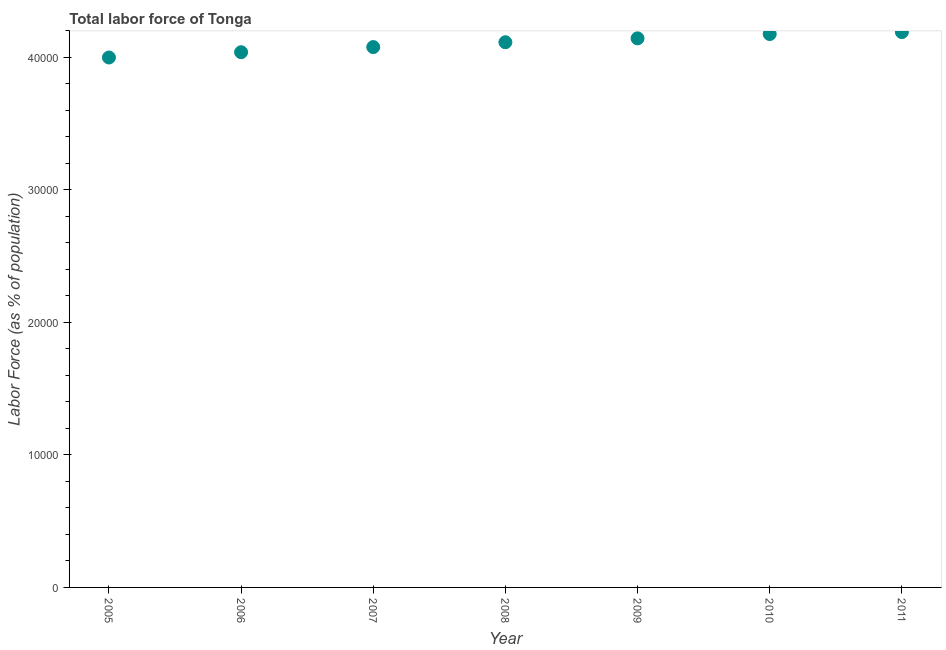What is the total labor force in 2005?
Provide a short and direct response. 4.00e+04. Across all years, what is the maximum total labor force?
Provide a short and direct response. 4.19e+04. Across all years, what is the minimum total labor force?
Keep it short and to the point. 4.00e+04. In which year was the total labor force minimum?
Keep it short and to the point. 2005. What is the sum of the total labor force?
Offer a very short reply. 2.87e+05. What is the difference between the total labor force in 2006 and 2009?
Give a very brief answer. -1046. What is the average total labor force per year?
Give a very brief answer. 4.11e+04. What is the median total labor force?
Provide a short and direct response. 4.11e+04. In how many years, is the total labor force greater than 26000 %?
Keep it short and to the point. 7. Do a majority of the years between 2005 and 2008 (inclusive) have total labor force greater than 12000 %?
Give a very brief answer. Yes. What is the ratio of the total labor force in 2006 to that in 2007?
Your response must be concise. 0.99. Is the total labor force in 2007 less than that in 2008?
Keep it short and to the point. Yes. What is the difference between the highest and the second highest total labor force?
Offer a terse response. 148. What is the difference between the highest and the lowest total labor force?
Offer a very short reply. 1917. In how many years, is the total labor force greater than the average total labor force taken over all years?
Your answer should be compact. 4. How many years are there in the graph?
Keep it short and to the point. 7. Does the graph contain grids?
Provide a short and direct response. No. What is the title of the graph?
Ensure brevity in your answer.  Total labor force of Tonga. What is the label or title of the Y-axis?
Your response must be concise. Labor Force (as % of population). What is the Labor Force (as % of population) in 2005?
Provide a succinct answer. 4.00e+04. What is the Labor Force (as % of population) in 2006?
Offer a terse response. 4.04e+04. What is the Labor Force (as % of population) in 2007?
Provide a succinct answer. 4.08e+04. What is the Labor Force (as % of population) in 2008?
Your answer should be compact. 4.11e+04. What is the Labor Force (as % of population) in 2009?
Give a very brief answer. 4.14e+04. What is the Labor Force (as % of population) in 2010?
Provide a succinct answer. 4.18e+04. What is the Labor Force (as % of population) in 2011?
Offer a terse response. 4.19e+04. What is the difference between the Labor Force (as % of population) in 2005 and 2006?
Your answer should be compact. -399. What is the difference between the Labor Force (as % of population) in 2005 and 2007?
Provide a succinct answer. -786. What is the difference between the Labor Force (as % of population) in 2005 and 2008?
Provide a short and direct response. -1151. What is the difference between the Labor Force (as % of population) in 2005 and 2009?
Offer a terse response. -1445. What is the difference between the Labor Force (as % of population) in 2005 and 2010?
Your answer should be compact. -1769. What is the difference between the Labor Force (as % of population) in 2005 and 2011?
Your answer should be very brief. -1917. What is the difference between the Labor Force (as % of population) in 2006 and 2007?
Give a very brief answer. -387. What is the difference between the Labor Force (as % of population) in 2006 and 2008?
Give a very brief answer. -752. What is the difference between the Labor Force (as % of population) in 2006 and 2009?
Offer a very short reply. -1046. What is the difference between the Labor Force (as % of population) in 2006 and 2010?
Ensure brevity in your answer.  -1370. What is the difference between the Labor Force (as % of population) in 2006 and 2011?
Offer a very short reply. -1518. What is the difference between the Labor Force (as % of population) in 2007 and 2008?
Give a very brief answer. -365. What is the difference between the Labor Force (as % of population) in 2007 and 2009?
Provide a short and direct response. -659. What is the difference between the Labor Force (as % of population) in 2007 and 2010?
Keep it short and to the point. -983. What is the difference between the Labor Force (as % of population) in 2007 and 2011?
Provide a succinct answer. -1131. What is the difference between the Labor Force (as % of population) in 2008 and 2009?
Your response must be concise. -294. What is the difference between the Labor Force (as % of population) in 2008 and 2010?
Give a very brief answer. -618. What is the difference between the Labor Force (as % of population) in 2008 and 2011?
Provide a short and direct response. -766. What is the difference between the Labor Force (as % of population) in 2009 and 2010?
Provide a succinct answer. -324. What is the difference between the Labor Force (as % of population) in 2009 and 2011?
Offer a very short reply. -472. What is the difference between the Labor Force (as % of population) in 2010 and 2011?
Offer a very short reply. -148. What is the ratio of the Labor Force (as % of population) in 2005 to that in 2006?
Give a very brief answer. 0.99. What is the ratio of the Labor Force (as % of population) in 2005 to that in 2007?
Keep it short and to the point. 0.98. What is the ratio of the Labor Force (as % of population) in 2005 to that in 2008?
Your answer should be compact. 0.97. What is the ratio of the Labor Force (as % of population) in 2005 to that in 2010?
Provide a short and direct response. 0.96. What is the ratio of the Labor Force (as % of population) in 2005 to that in 2011?
Provide a succinct answer. 0.95. What is the ratio of the Labor Force (as % of population) in 2006 to that in 2011?
Make the answer very short. 0.96. What is the ratio of the Labor Force (as % of population) in 2007 to that in 2009?
Your answer should be compact. 0.98. What is the ratio of the Labor Force (as % of population) in 2007 to that in 2011?
Your answer should be very brief. 0.97. What is the ratio of the Labor Force (as % of population) in 2009 to that in 2011?
Give a very brief answer. 0.99. 